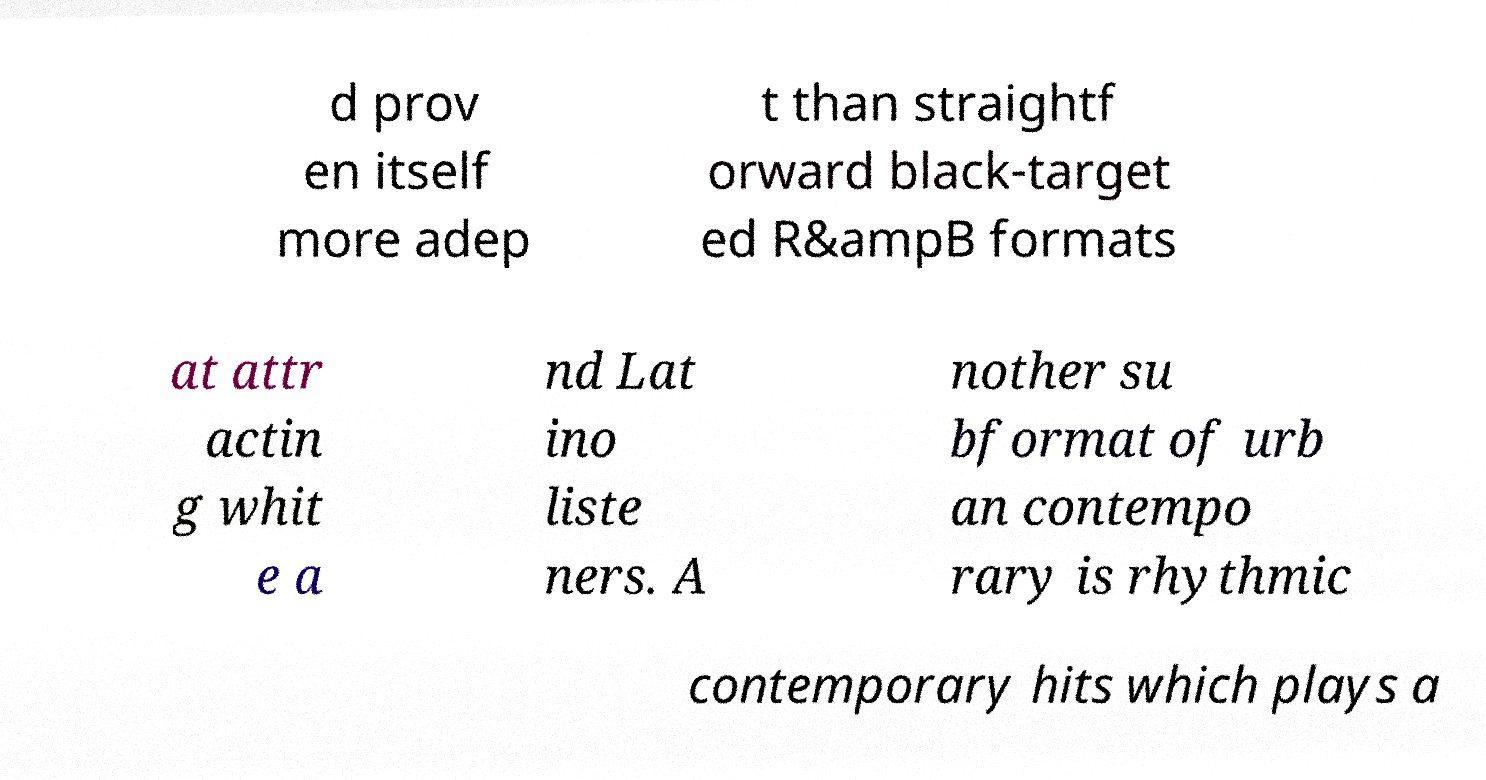Please identify and transcribe the text found in this image. d prov en itself more adep t than straightf orward black-target ed R&ampB formats at attr actin g whit e a nd Lat ino liste ners. A nother su bformat of urb an contempo rary is rhythmic contemporary hits which plays a 